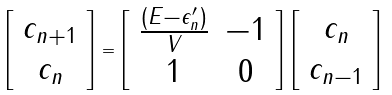Convert formula to latex. <formula><loc_0><loc_0><loc_500><loc_500>\left [ \begin{array} { c } c _ { n + 1 } \\ c _ { n } \end{array} \right ] = \left [ \begin{array} { c c } \frac { ( E - \epsilon _ { n } ^ { \prime } ) } { V } & - 1 \\ 1 & 0 \end{array} \right ] \left [ \begin{array} { c } c _ { n } \\ c _ { n - 1 } \end{array} \right ]</formula> 